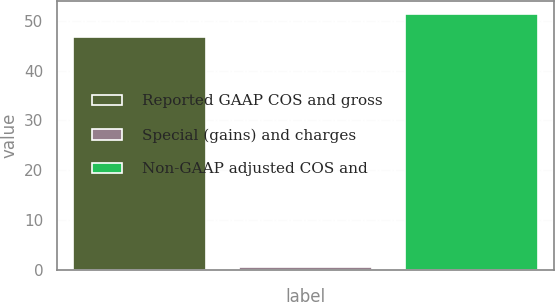Convert chart to OTSL. <chart><loc_0><loc_0><loc_500><loc_500><bar_chart><fcel>Reported GAAP COS and gross<fcel>Special (gains) and charges<fcel>Non-GAAP adjusted COS and<nl><fcel>46.7<fcel>0.6<fcel>51.37<nl></chart> 